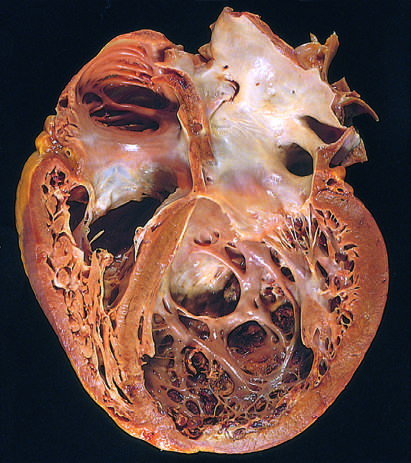s the pattern of staining of anti-centromere antibodies evident?
Answer the question using a single word or phrase. No 